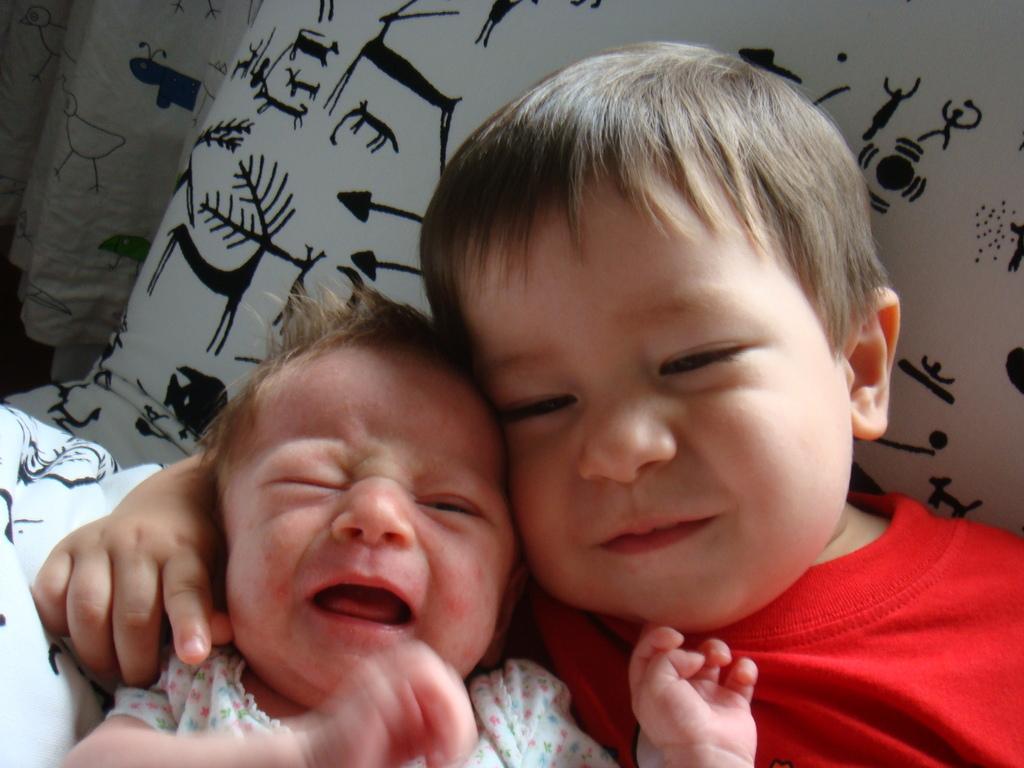Describe this image in one or two sentences. In this picture there is a small boy wearing red t-shirt is lying on the white color pillow. Beside there is a small baby who is crying. 